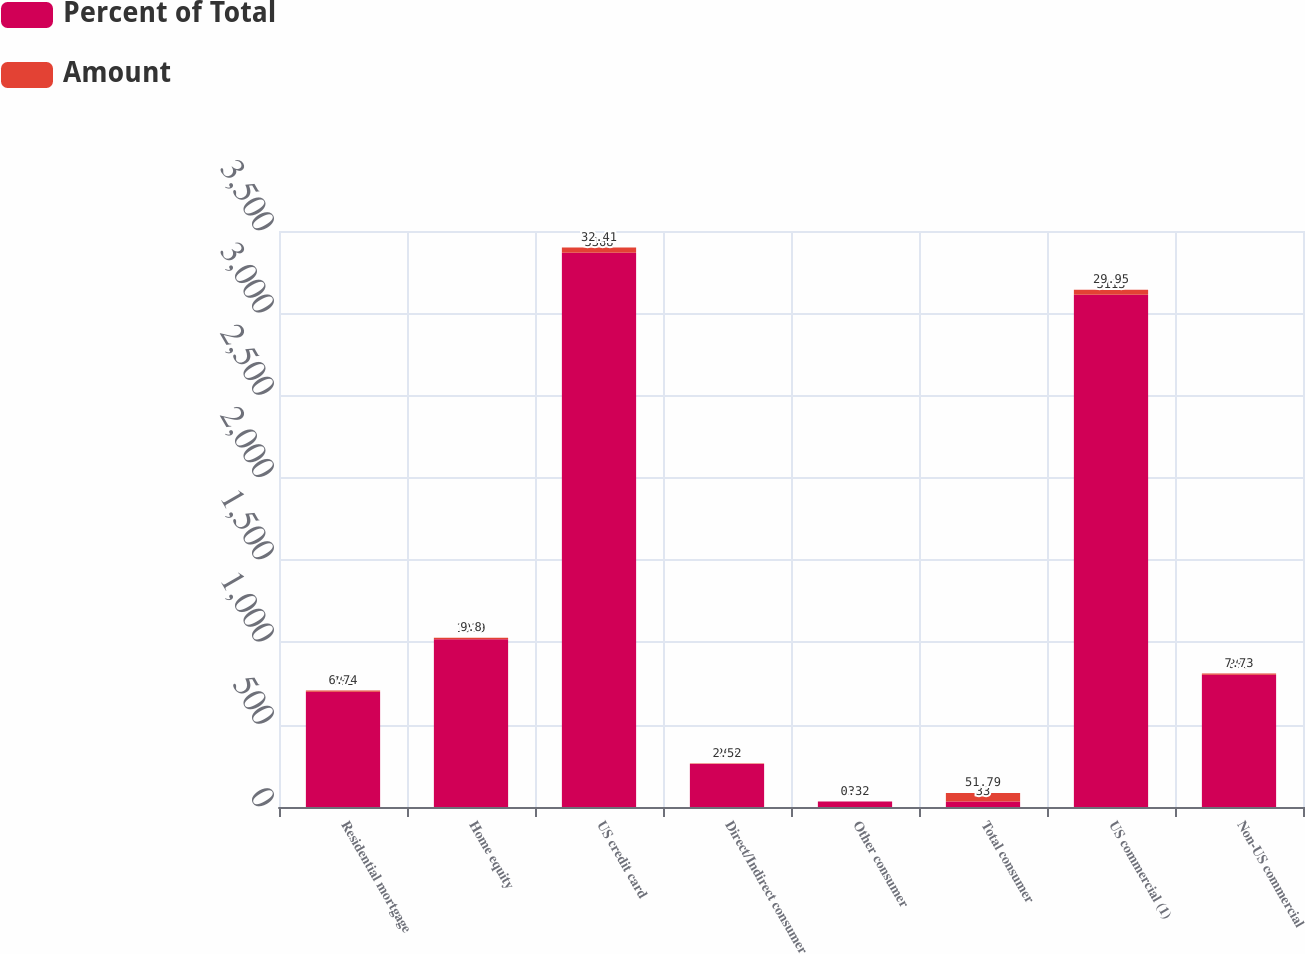Convert chart. <chart><loc_0><loc_0><loc_500><loc_500><stacked_bar_chart><ecel><fcel>Residential mortgage<fcel>Home equity<fcel>US credit card<fcel>Direct/Indirect consumer<fcel>Other consumer<fcel>Total consumer<fcel>US commercial (1)<fcel>Non-US commercial<nl><fcel>Percent of Total<fcel>701<fcel>1019<fcel>3368<fcel>262<fcel>33<fcel>33<fcel>3113<fcel>803<nl><fcel>Amount<fcel>6.74<fcel>9.8<fcel>32.41<fcel>2.52<fcel>0.32<fcel>51.79<fcel>29.95<fcel>7.73<nl></chart> 